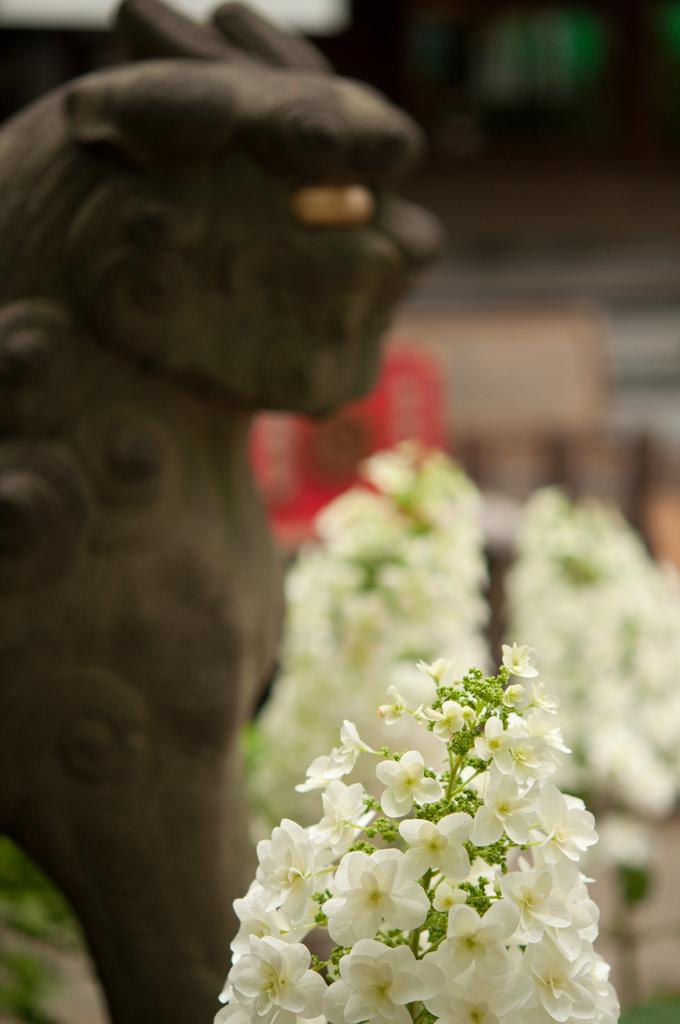What type of living organisms can be seen in the image? There are flowers in the image. What color are the flowers? The flowers are white in color. What other object can be seen in the background of the image? There is a statue in the background of the image. What color is the statue? The statue is brown in color. What type of doctor can be seen treating the spiders in the image? There are no doctors or spiders present in the image. How does the doctor crush the spiders in the image? There is no doctor or spiders present in the image, so it is not possible to answer that question. 